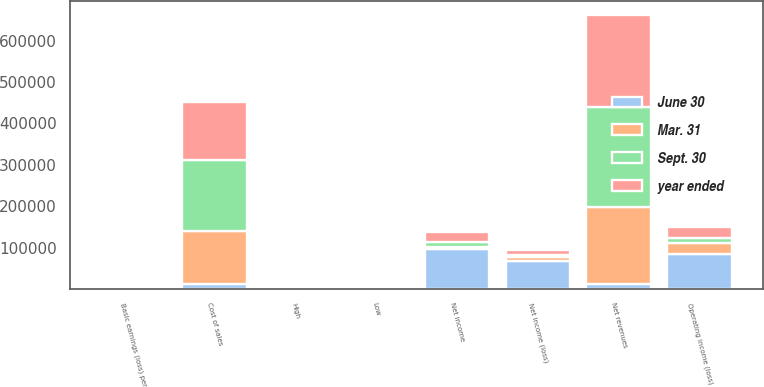<chart> <loc_0><loc_0><loc_500><loc_500><stacked_bar_chart><ecel><fcel>Net revenues<fcel>Cost of sales<fcel>Operating income (loss)<fcel>Net income (loss)<fcel>Basic earnings (loss) per<fcel>High<fcel>Low<fcel>Net income<nl><fcel>Sept. 30<fcel>241093<fcel>172270<fcel>13448<fcel>3585<fcel>0.01<fcel>13.88<fcel>10.64<fcel>11957<nl><fcel>year ended<fcel>222540<fcel>141458<fcel>26547<fcel>13242<fcel>0.05<fcel>17.3<fcel>12.07<fcel>25543<nl><fcel>June 30<fcel>10588<fcel>10588<fcel>84067<fcel>67945<fcel>0.25<fcel>18.03<fcel>12.94<fcel>97262<nl><fcel>Mar. 31<fcel>188125<fcel>128309<fcel>26115<fcel>9219<fcel>0.03<fcel>15.93<fcel>11.81<fcel>3573<nl></chart> 